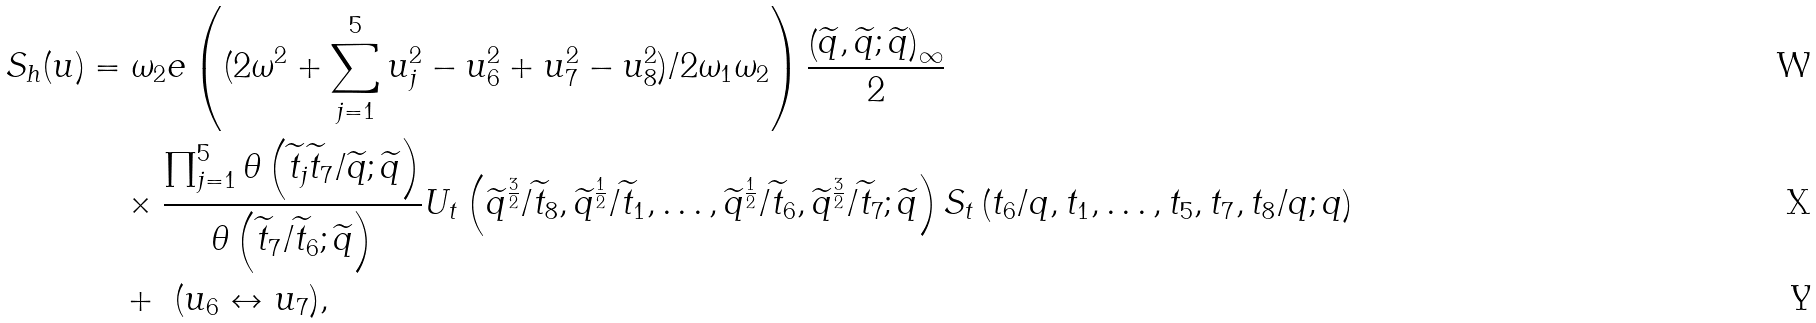<formula> <loc_0><loc_0><loc_500><loc_500>S _ { h } ( u ) & = \omega _ { 2 } e \left ( ( 2 \omega ^ { 2 } + \sum _ { j = 1 } ^ { 5 } u _ { j } ^ { 2 } - u _ { 6 } ^ { 2 } + u _ { 7 } ^ { 2 } - u _ { 8 } ^ { 2 } ) / 2 \omega _ { 1 } \omega _ { 2 } \right ) \frac { \left ( \widetilde { q } , \widetilde { q } ; \widetilde { q } \right ) _ { \infty } } { 2 } \\ & \quad \times \frac { \prod _ { j = 1 } ^ { 5 } \theta \left ( \widetilde { t } _ { j } \widetilde { t } _ { 7 } / \widetilde { q } ; \widetilde { q } \right ) } { \theta \left ( \widetilde { t } _ { 7 } / \widetilde { t } _ { 6 } ; \widetilde { q } \right ) } U _ { t } \left ( \widetilde { q } ^ { \frac { 3 } { 2 } } / \widetilde { t } _ { 8 } , \widetilde { q } ^ { \frac { 1 } { 2 } } / \widetilde { t } _ { 1 } , \dots , \widetilde { q } ^ { \frac { 1 } { 2 } } / \widetilde { t } _ { 6 } , \widetilde { q } ^ { \frac { 3 } { 2 } } / \widetilde { t } _ { 7 } ; \widetilde { q } \right ) S _ { t } \left ( t _ { 6 } / q , t _ { 1 } , \dots , t _ { 5 } , t _ { 7 } , t _ { 8 } / q ; q \right ) \\ & \quad + \ ( u _ { 6 } \leftrightarrow u _ { 7 } ) ,</formula> 